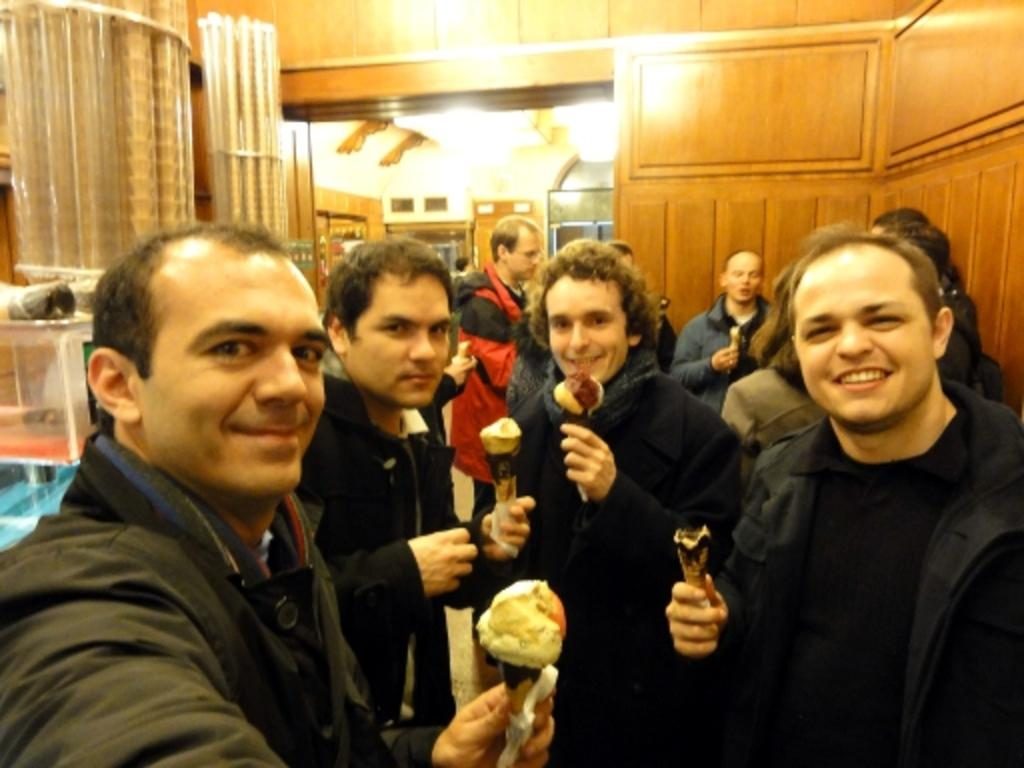What are the people in the image holding? The people in the image are holding ice creams. Can you describe the scene in the background of the image? In the background of the image, there are other people, lights, a wall, and various objects. How many people can be seen in the image? There are people standing in the image, and there are other people visible in the background. What is the name of the actor who plays the main character in the image? There is no actor or main character in the image, as it is a scene of people holding ice creams and a background setting. 